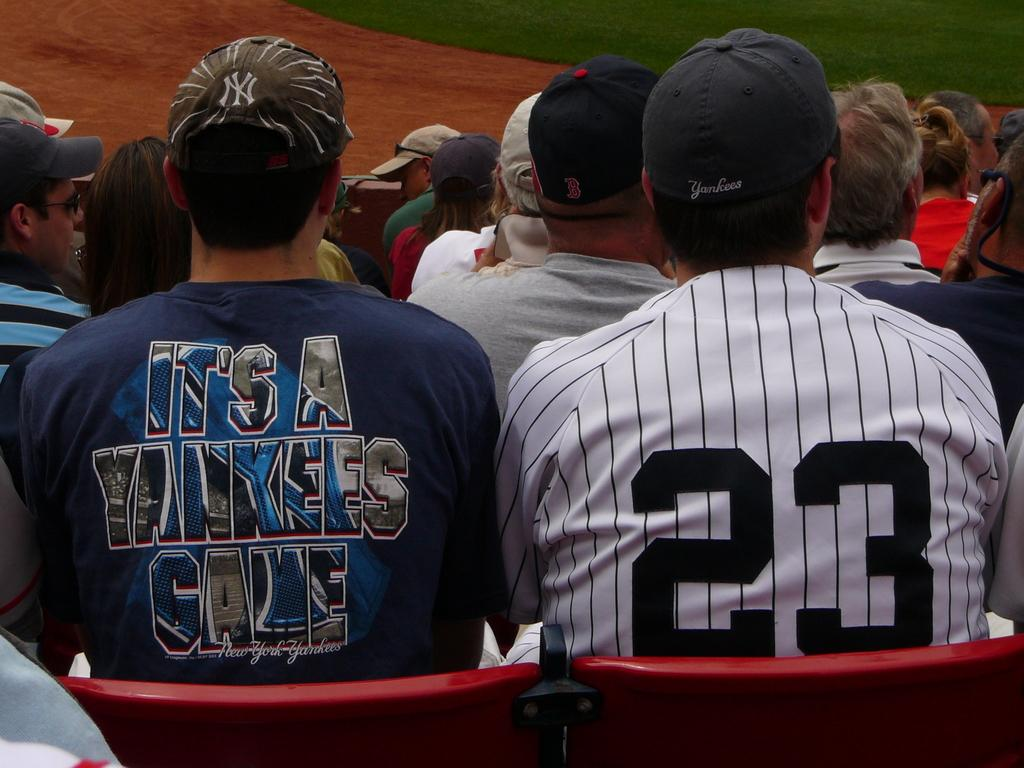<image>
Share a concise interpretation of the image provided. Two Yankees fans sit next to each other. 